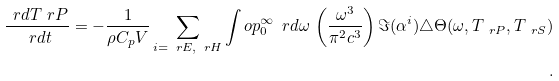Convert formula to latex. <formula><loc_0><loc_0><loc_500><loc_500>\frac { \ r d T _ { \ } r P } { \ r d t } = - \frac { 1 } { \rho C _ { p } V } \sum _ { i = \ r E , \ r H } \int o p _ { 0 } ^ { \infty } \ r d \omega \, \left ( \frac { \omega ^ { 3 } } { \pi ^ { 2 } c ^ { 3 } } \right ) \Im ( \alpha ^ { i } ) \triangle \Theta ( \omega , T _ { \ r P } , T _ { \ r S } ) \\ .</formula> 